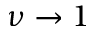<formula> <loc_0><loc_0><loc_500><loc_500>\nu \to 1</formula> 